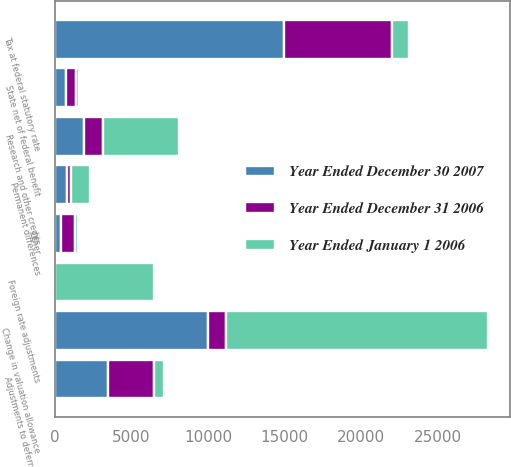Convert chart. <chart><loc_0><loc_0><loc_500><loc_500><stacked_bar_chart><ecel><fcel>Tax at federal statutory rate<fcel>State net of federal benefit<fcel>Research and other credits<fcel>Adjustments to deferred tax<fcel>Change in valuation allowance<fcel>Permanent differences<fcel>Foreign rate adjustments<fcel>Other<nl><fcel>Year Ended January 1 2006<fcel>1138<fcel>174<fcel>4981<fcel>690<fcel>17125<fcel>1229<fcel>6426<fcel>226<nl><fcel>Year Ended December 30 2007<fcel>14945<fcel>767<fcel>1900<fcel>3509<fcel>10038<fcel>818<fcel>3<fcel>441<nl><fcel>Year Ended December 31 2006<fcel>7043<fcel>633<fcel>1239<fcel>2952<fcel>1138<fcel>226<fcel>28<fcel>880<nl></chart> 